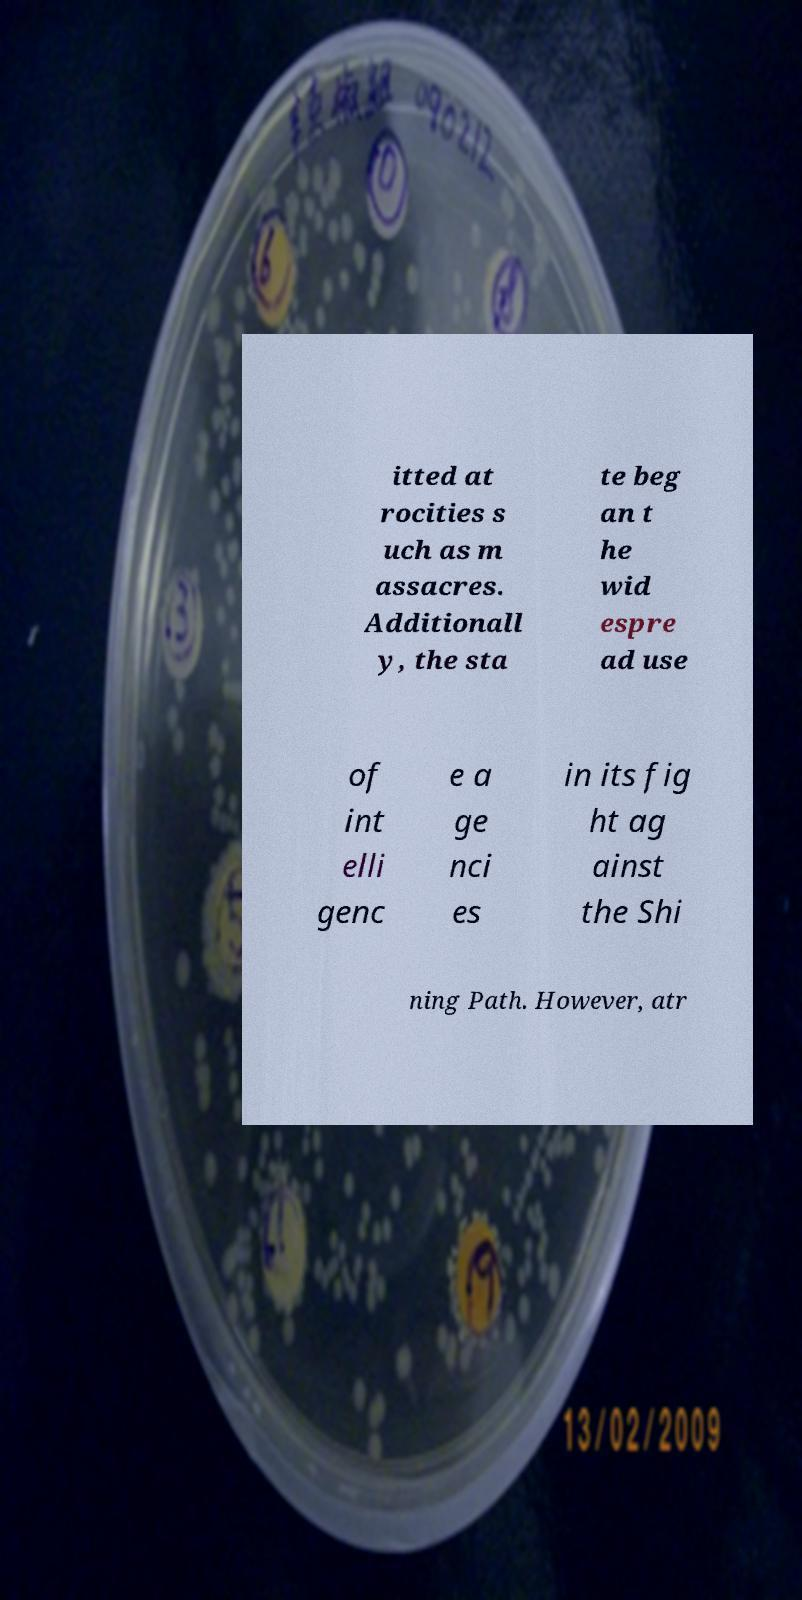What messages or text are displayed in this image? I need them in a readable, typed format. itted at rocities s uch as m assacres. Additionall y, the sta te beg an t he wid espre ad use of int elli genc e a ge nci es in its fig ht ag ainst the Shi ning Path. However, atr 